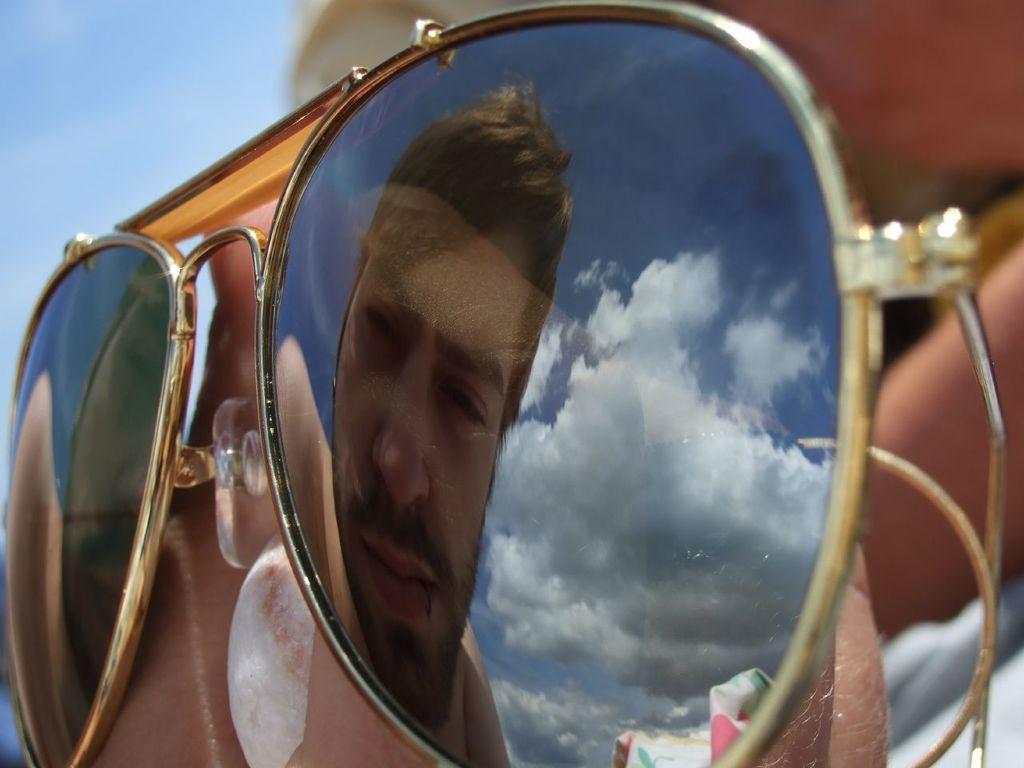Can you describe this image briefly? In this image in the foreground there is one person who is wearing goggles, and in the goggles we could see the reflection of one person and on the top of the image there is sky. 